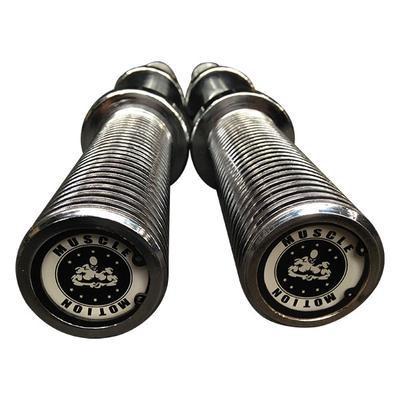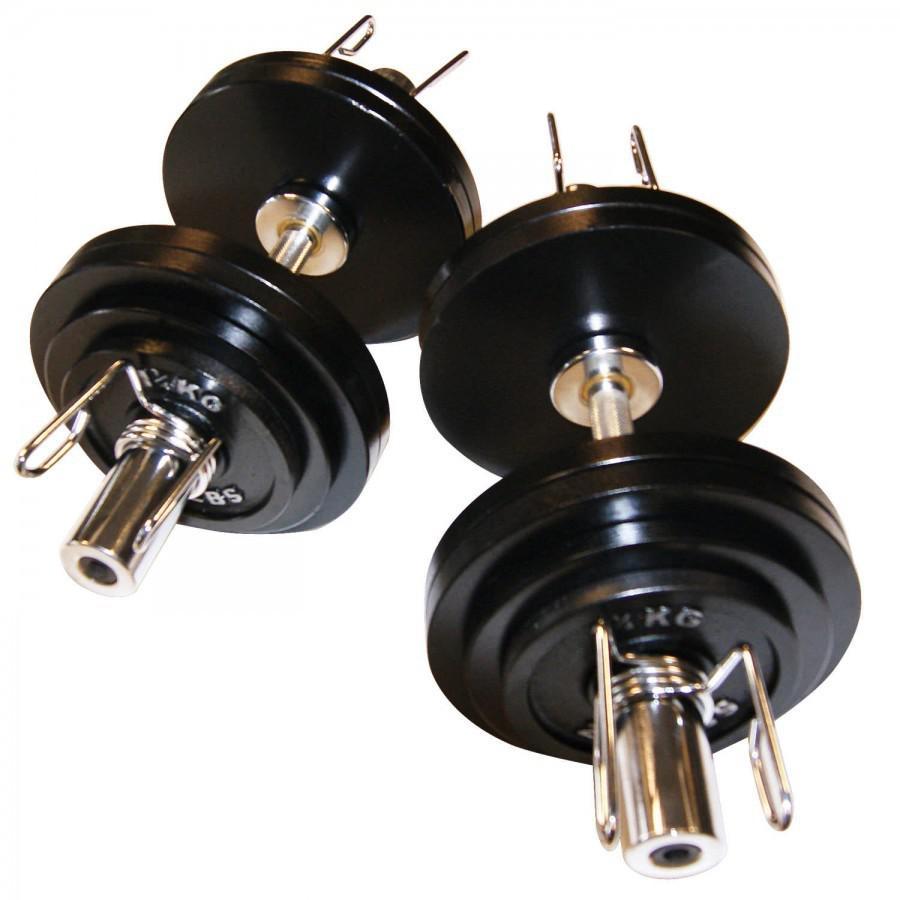The first image is the image on the left, the second image is the image on the right. For the images displayed, is the sentence "There are a total of four dumbbell bars with only two having weight on them." factually correct? Answer yes or no. Yes. 